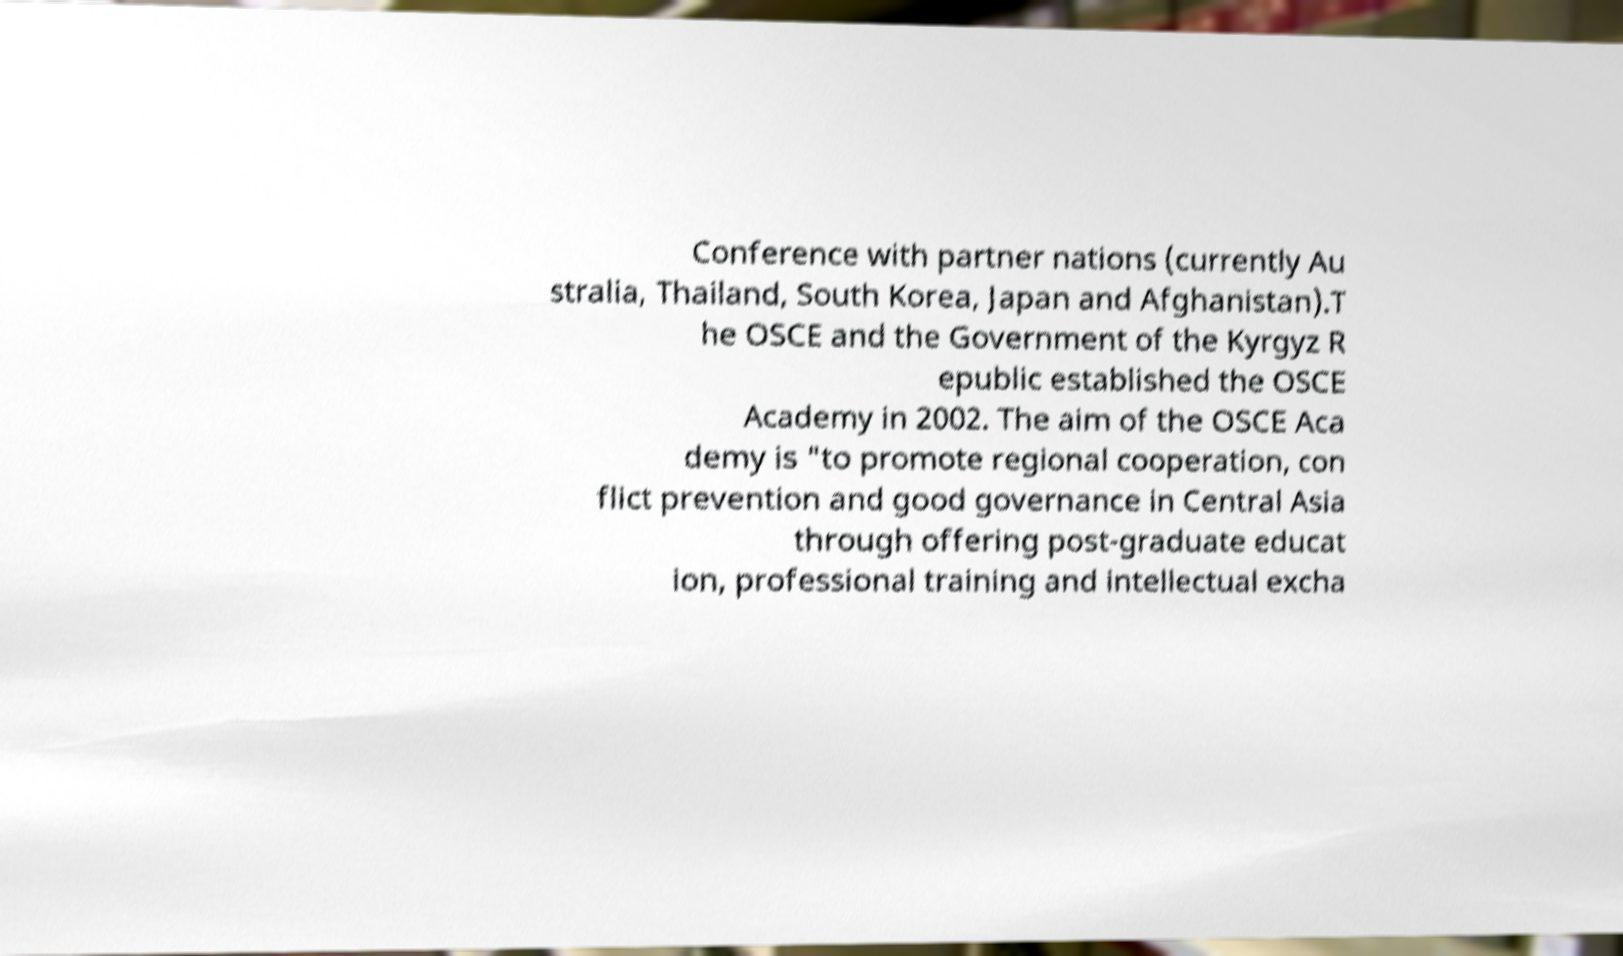Please identify and transcribe the text found in this image. Conference with partner nations (currently Au stralia, Thailand, South Korea, Japan and Afghanistan).T he OSCE and the Government of the Kyrgyz R epublic established the OSCE Academy in 2002. The aim of the OSCE Aca demy is "to promote regional cooperation, con flict prevention and good governance in Central Asia through offering post-graduate educat ion, professional training and intellectual excha 